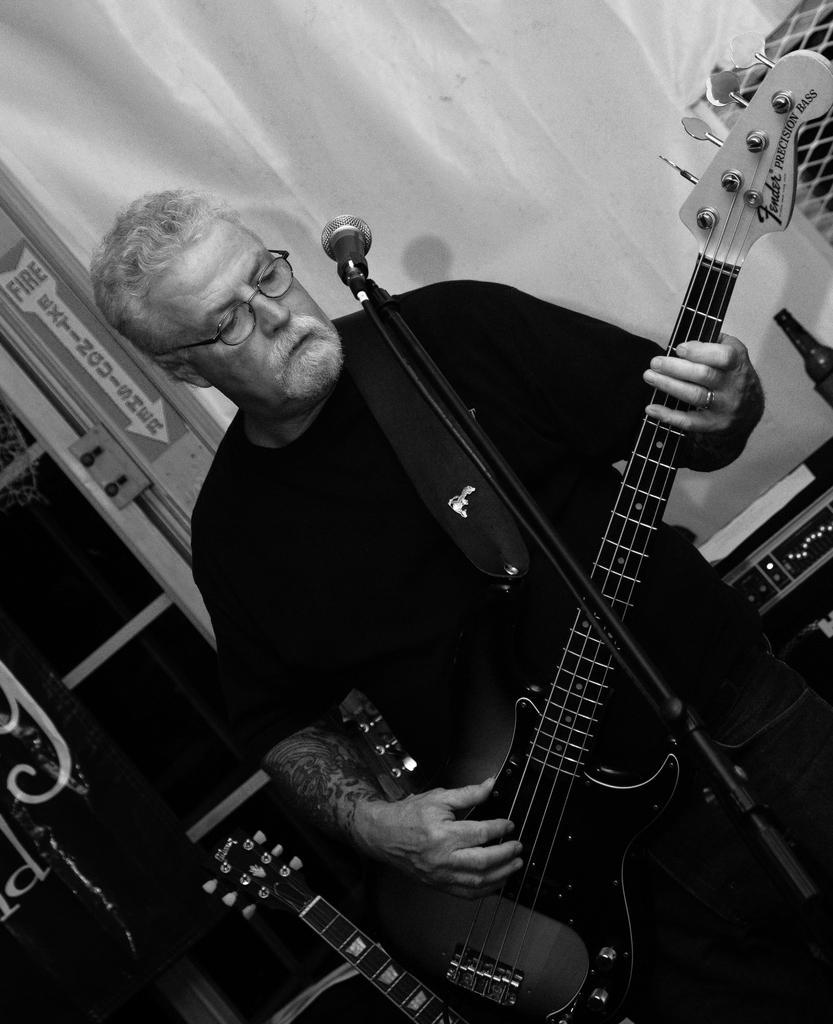Could you give a brief overview of what you see in this image? In the image there is a middle aged man who is playing a guitar. He is wearing a black shirt. There is a mic placed before him. In the background there is a bottle, a curtain and a door. 